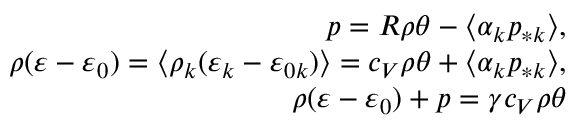Convert formula to latex. <formula><loc_0><loc_0><loc_500><loc_500>\begin{array} { r } { p = R \rho \theta - \langle \alpha _ { k } p _ { * k } \rangle , } \\ { \rho ( \varepsilon - \varepsilon _ { 0 } ) = \langle \rho _ { k } ( \varepsilon _ { k } - \varepsilon _ { 0 k } ) \rangle = c _ { V } \rho \theta + \langle \alpha _ { k } p _ { * k } \rangle , } \\ { \rho ( \varepsilon - \varepsilon _ { 0 } ) + p = \gamma c _ { V } \rho \theta } \end{array}</formula> 